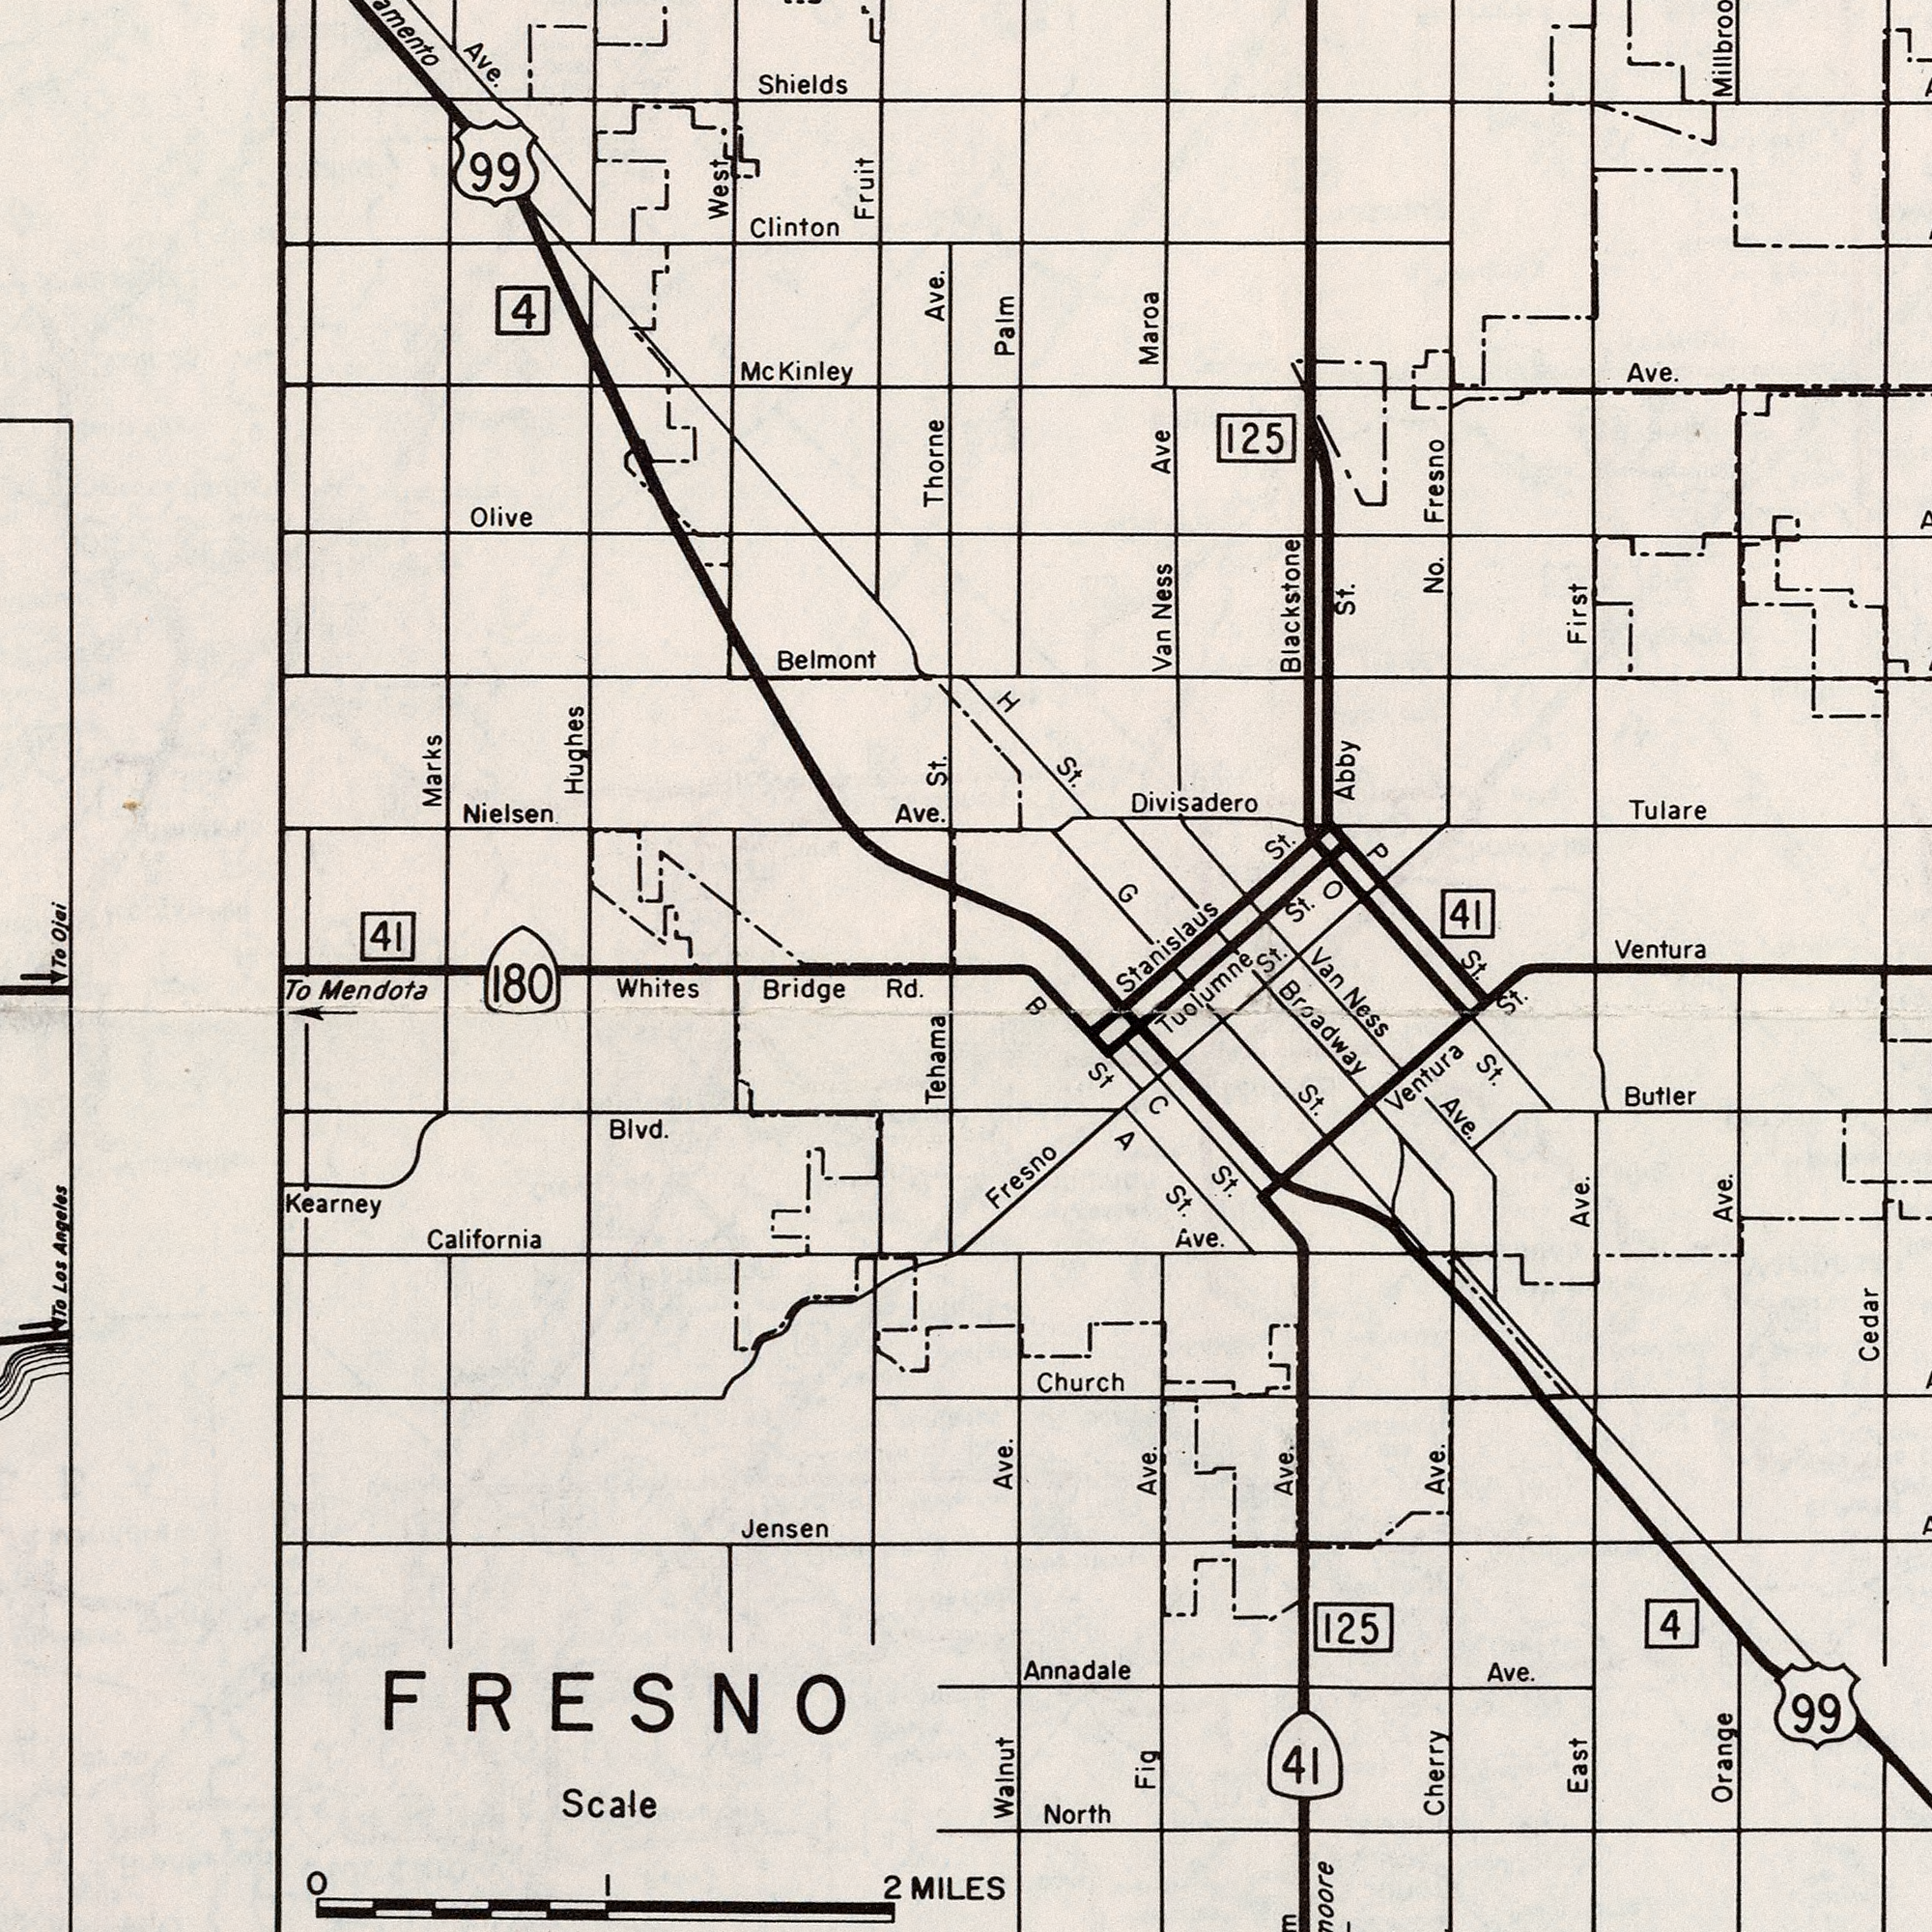What text can you see in the top-right section? Maroa Abby St. Tulare No. Van Ness Ave Stanislaus St. Ventura St. Fresno 125 Ave. First Divisadero Blackstone H St. G Palm 41 P St. St. O What text is visible in the lower-left corner? Tehama To Los Angeles To Mendota Scale Jensen Blvd. Whites Bridge Rd. Kearney 2 MILES 180 FRESNO California 1 0 What text is shown in the bottom-right quadrant? Tuolumne St. Ave. Walnut Ave. Orange Ave. North Annadale Ave. Cherry Ave. Fig Ave. Ventura St. Cedar East Ave. Van Ness Ave. Ave. Fresno St. A St. Butler 99 125 B St Church C St. 4 41 Broadway What text is visible in the upper-left corner? Shields Hughes Clinton Nielsen Ave. 99 Ave. Belmont Thorne Ave. Olive Marks 41 West St. 4 Fruit Kinley To Ojai 